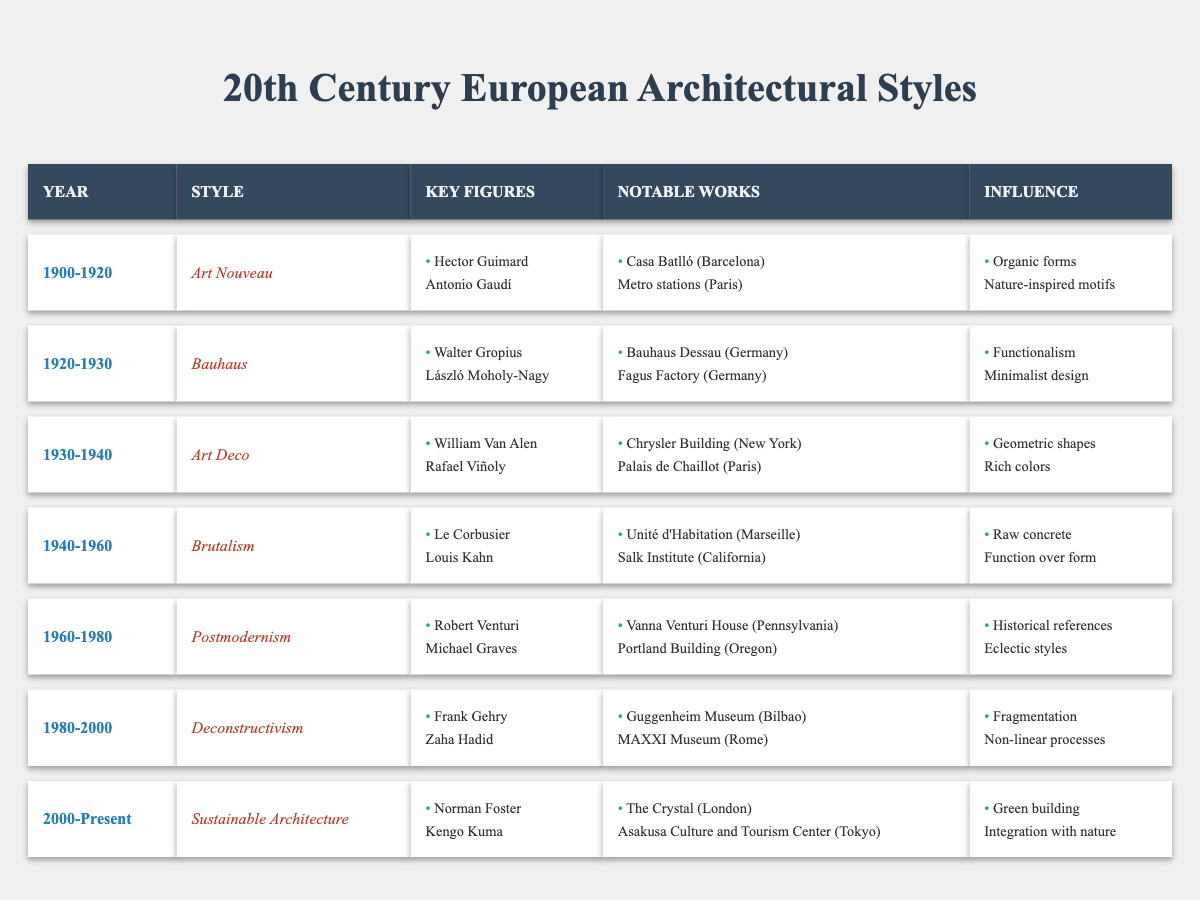What architectural style was prominent from 1940 to 1960? The table clearly lists the style for that period as "Brutalism."
Answer: Brutalism Who are the key figures associated with Deconstructivism? For the period of 1980-2000, the table mentions Frank Gehry and Zaha Hadid as key figures for Deconstructivism.
Answer: Frank Gehry and Zaha Hadid Is it true that Art Deco is associated with functionalism? The table indicates that Art Deco influences were geometric shapes and rich colors, so it is not associated with functionalism, which is instead linked to Bauhaus.
Answer: No What notable work represents Art Nouveau? The table lists "Casa Batlló (Barcelona)" and "Metro stations (Paris)" as notable works for the Art Nouveau style.
Answer: Casa Batlló (Barcelona) Which architectural styles mentioned in the table emphasize integration with nature? Only the "Sustainable Architecture" style from 2000 onwards emphasizes integration with nature, as indicated in the influence section of the table.
Answer: Sustainable Architecture What is the influence of the Postmodernism style? The influence of Postmodernism, covering the years 1960-1980, is described as historical references and eclectic styles in the table.
Answer: Historical references and eclectic styles Comparing the periods, how many architectural styles have a focus on geometric shapes? From the table, Art Deco (1930-1940) and Postmodernism (1960-1980) both have geometric shapes as defining influences. Therefore, there are two styles focused on this aspect.
Answer: Two styles Which style has notable works by Le Corbusier? The table associates Le Corbusier with the "Brutalism" style, and his notable work is the "Unité d'Habitation."
Answer: Brutalism What years cover the influence of Deconstructivism? The Deconstructivism style is associated with the years 1980 to 2000 based on the table.
Answer: 1980-2000 List the architectural styles in order from the table. The styles in order based on the years are: Art Nouveau, Bauhaus, Art Deco, Brutalism, Postmodernism, Deconstructivism, Sustainable Architecture.
Answer: Art Nouveau, Bauhaus, Art Deco, Brutalism, Postmodernism, Deconstructivism, Sustainable Architecture 